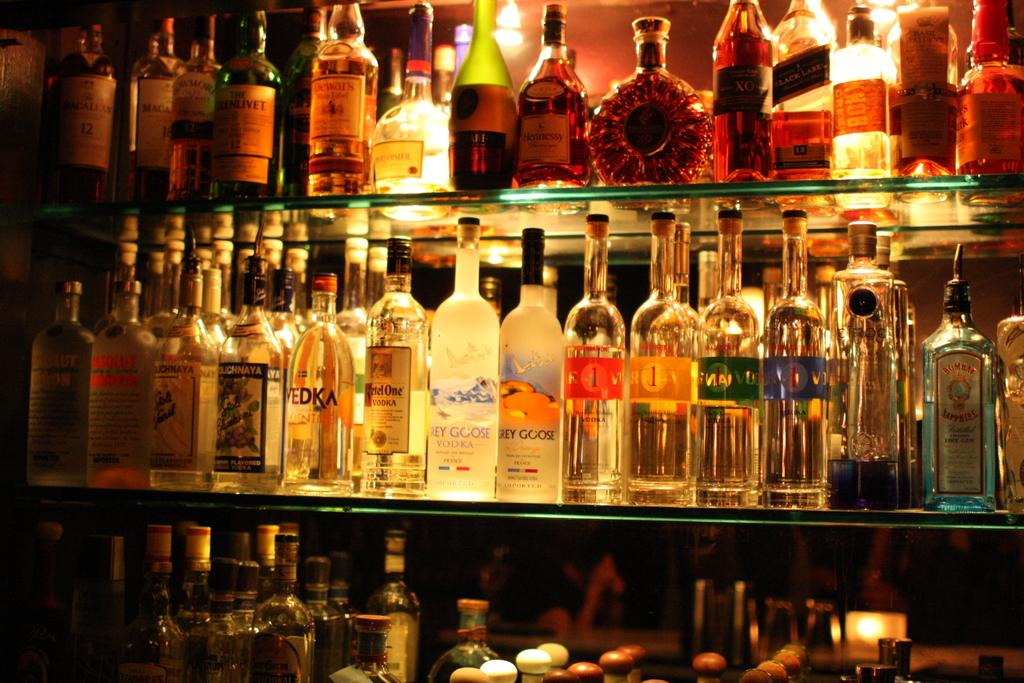<image>
Present a compact description of the photo's key features. bottles of liquor lined up on glass bar shelves include Ketel One Vodka 